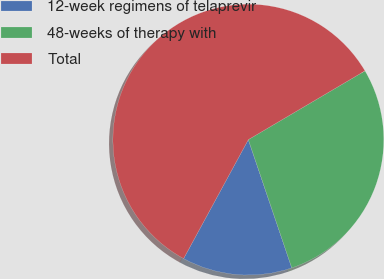<chart> <loc_0><loc_0><loc_500><loc_500><pie_chart><fcel>12-week regimens of telaprevir<fcel>48-weeks of therapy with<fcel>Total<nl><fcel>13.13%<fcel>28.28%<fcel>58.59%<nl></chart> 